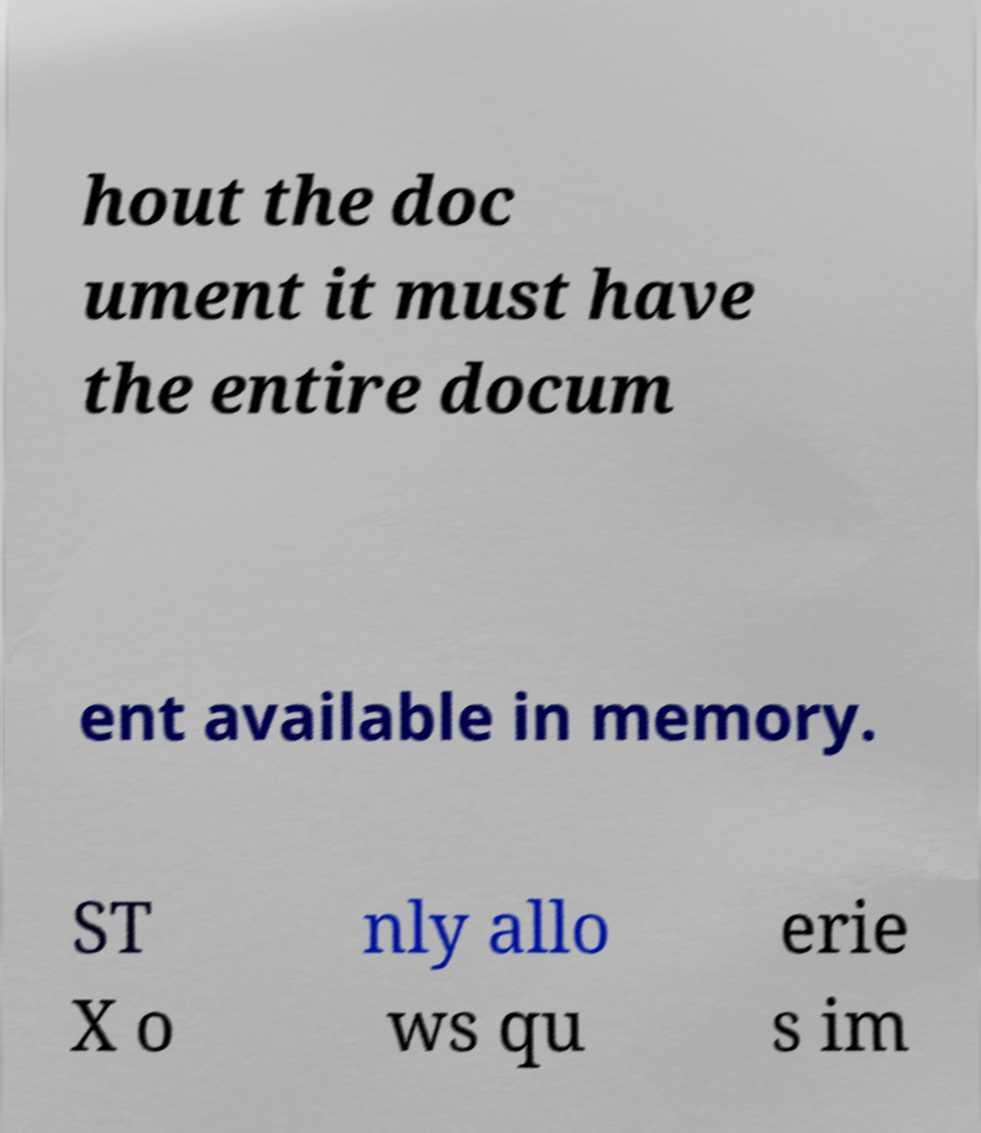Could you assist in decoding the text presented in this image and type it out clearly? hout the doc ument it must have the entire docum ent available in memory. ST X o nly allo ws qu erie s im 